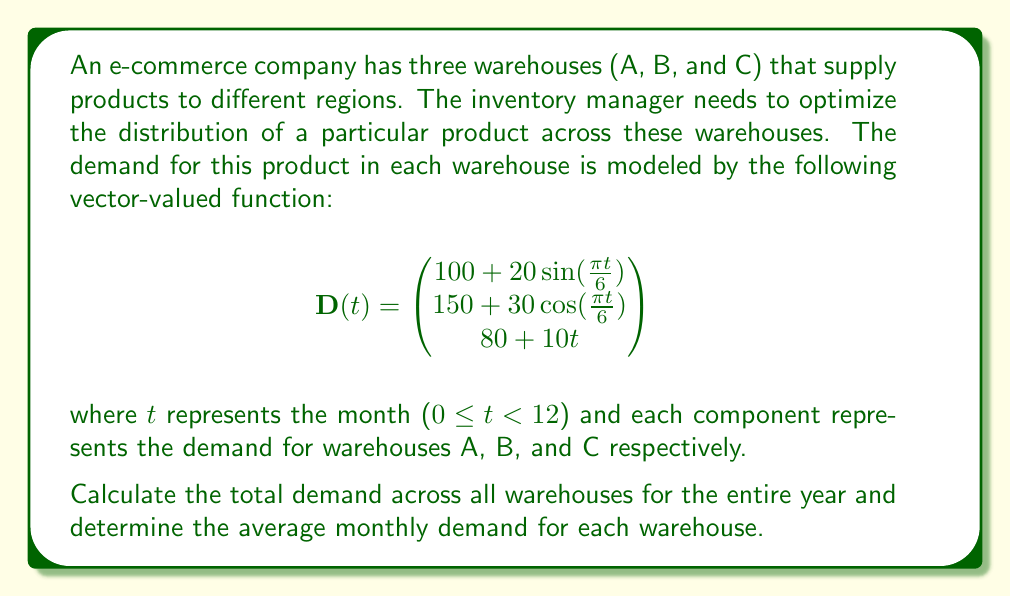Provide a solution to this math problem. To solve this problem, we need to follow these steps:

1. Calculate the total demand for each warehouse over the year:
   - For warehouse A and B, we need to integrate their demand functions over the interval [0, 12].
   - For warehouse C, we can directly calculate the demand as it's a linear function.

2. Sum up the demands from all warehouses to get the total annual demand.

3. Divide the total annual demand by 12 to get the average monthly demand for each warehouse.

Let's start with the calculations:

1. For warehouse A:
   $$\int_0^{12} (100 + 20\sin(\frac{\pi t}{6})) dt = 100t - \frac{120}{\pi}\cos(\frac{\pi t}{6}) \bigg|_0^{12}$$
   $$= (1200 - \frac{120}{\pi}) - (0 - \frac{120}{\pi}) = 1200$$

2. For warehouse B:
   $$\int_0^{12} (150 + 30\cos(\frac{\pi t}{6})) dt = 150t + \frac{180}{\pi}\sin(\frac{\pi t}{6}) \bigg|_0^{12}$$
   $$= (1800 + 0) - (0 + 0) = 1800$$

3. For warehouse C:
   $$\int_0^{12} (80 + 10t) dt = 80t + 5t^2 \bigg|_0^{12}$$
   $$= (960 + 720) - (0 + 0) = 1680$$

Total annual demand = 1200 + 1800 + 1680 = 4680 units

Average monthly demand for each warehouse:
- Warehouse A: 1200 / 12 = 100 units/month
- Warehouse B: 1800 / 12 = 150 units/month
- Warehouse C: 1680 / 12 = 140 units/month
Answer: The total demand across all warehouses for the entire year is 4680 units.
The average monthly demand for each warehouse is:
Warehouse A: 100 units/month
Warehouse B: 150 units/month
Warehouse C: 140 units/month 